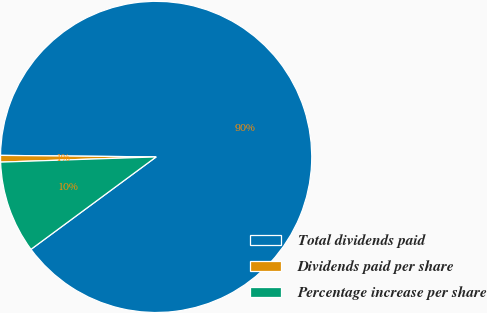Convert chart. <chart><loc_0><loc_0><loc_500><loc_500><pie_chart><fcel>Total dividends paid<fcel>Dividends paid per share<fcel>Percentage increase per share<nl><fcel>89.72%<fcel>0.69%<fcel>9.59%<nl></chart> 